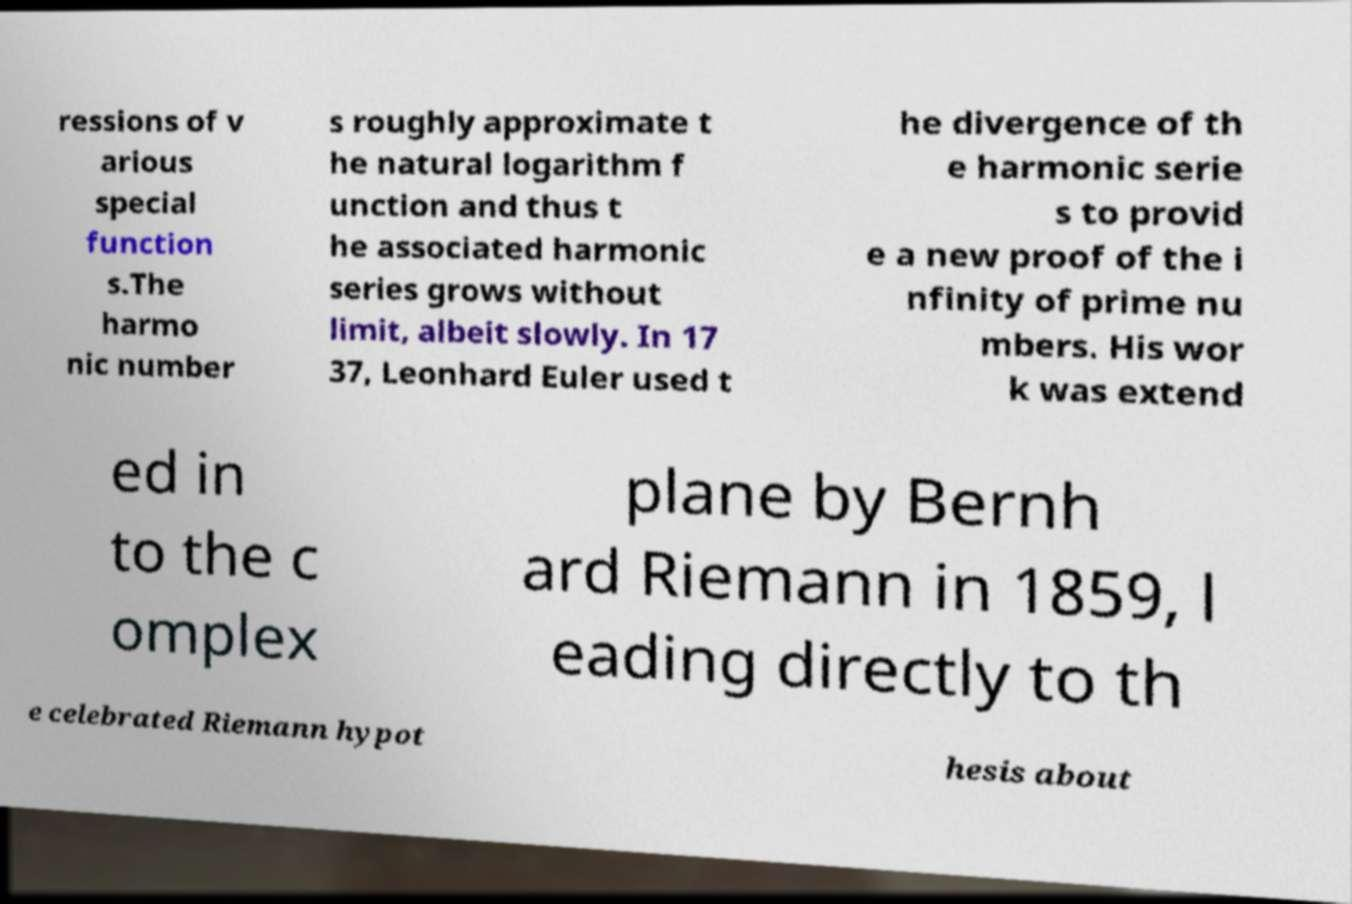Can you read and provide the text displayed in the image?This photo seems to have some interesting text. Can you extract and type it out for me? ressions of v arious special function s.The harmo nic number s roughly approximate t he natural logarithm f unction and thus t he associated harmonic series grows without limit, albeit slowly. In 17 37, Leonhard Euler used t he divergence of th e harmonic serie s to provid e a new proof of the i nfinity of prime nu mbers. His wor k was extend ed in to the c omplex plane by Bernh ard Riemann in 1859, l eading directly to th e celebrated Riemann hypot hesis about 